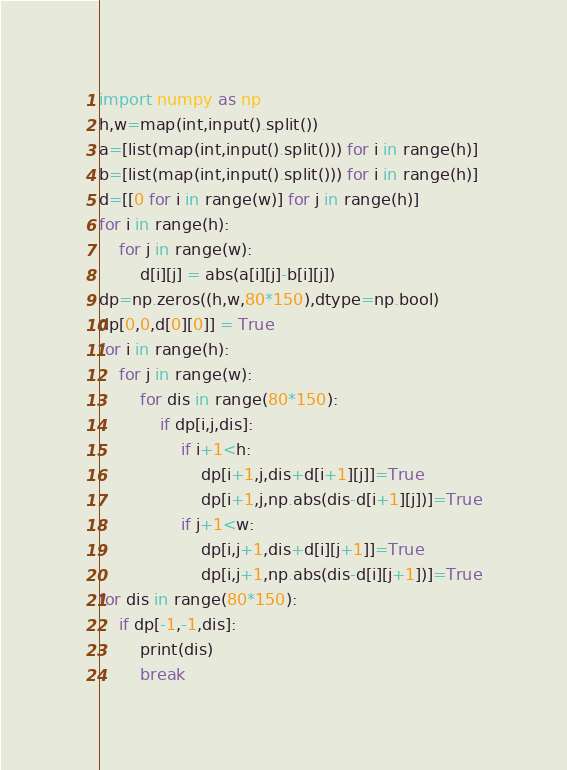<code> <loc_0><loc_0><loc_500><loc_500><_Python_>import numpy as np
h,w=map(int,input().split())
a=[list(map(int,input().split())) for i in range(h)]
b=[list(map(int,input().split())) for i in range(h)]
d=[[0 for i in range(w)] for j in range(h)]
for i in range(h):
    for j in range(w):
        d[i][j] = abs(a[i][j]-b[i][j])
dp=np.zeros((h,w,80*150),dtype=np.bool)
dp[0,0,d[0][0]] = True
for i in range(h):
    for j in range(w):
        for dis in range(80*150):
            if dp[i,j,dis]:
                if i+1<h:
                    dp[i+1,j,dis+d[i+1][j]]=True
                    dp[i+1,j,np.abs(dis-d[i+1][j])]=True
                if j+1<w:
                    dp[i,j+1,dis+d[i][j+1]]=True
                    dp[i,j+1,np.abs(dis-d[i][j+1])]=True
for dis in range(80*150):
    if dp[-1,-1,dis]:
        print(dis)
        break</code> 